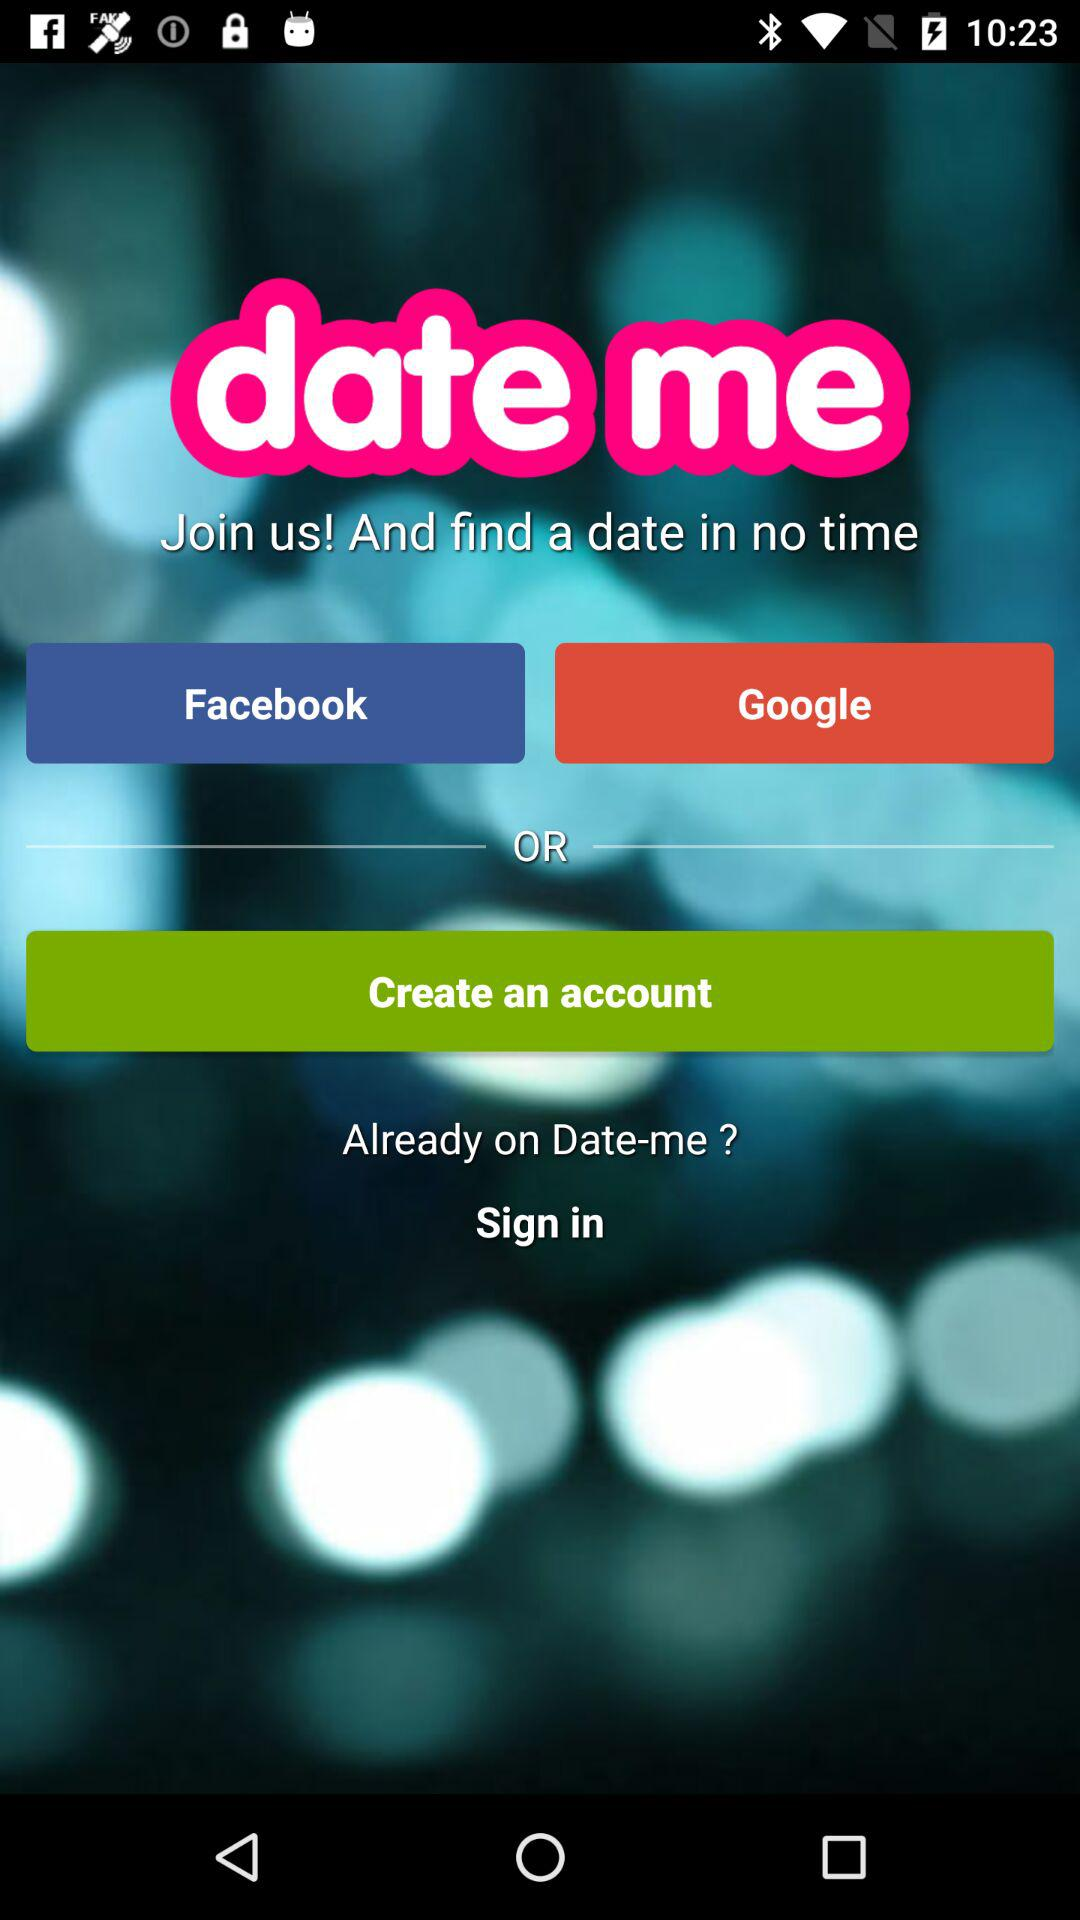What accounts can I use to sign in? The accounts that you can use to sign in are "Facebook" and "Google". 